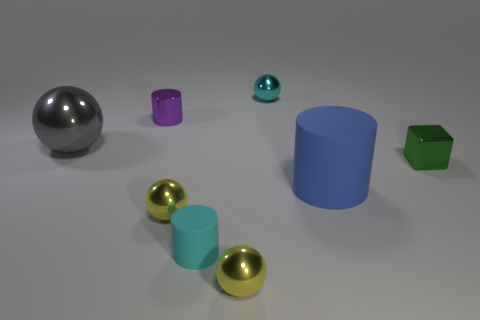Add 1 large gray objects. How many objects exist? 9 Subtract all cyan blocks. Subtract all gray spheres. How many blocks are left? 1 Subtract all cylinders. How many objects are left? 5 Add 7 big blue cylinders. How many big blue cylinders are left? 8 Add 7 cyan rubber objects. How many cyan rubber objects exist? 8 Subtract 1 purple cylinders. How many objects are left? 7 Subtract all metallic things. Subtract all small cyan balls. How many objects are left? 1 